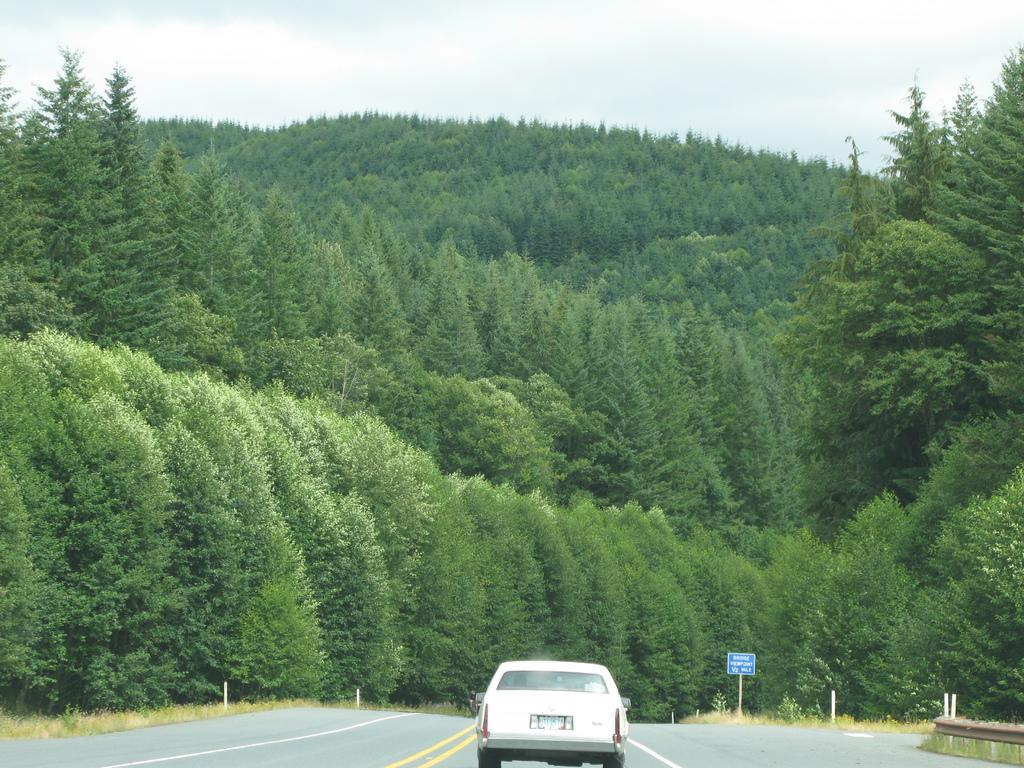What is on the road in the image? There is a car on the road in the image. What can be seen in the background of the image? There are trees in the background. What is attached to the pole in the image? There is a sign board on the pole. What is visible above the trees and the car? The sky is visible. Where is the dock located in the image? There is no dock present in the image. What type of bomb is depicted on the sign board in the image? There is no bomb depicted on the sign board or anywhere else in the image. 